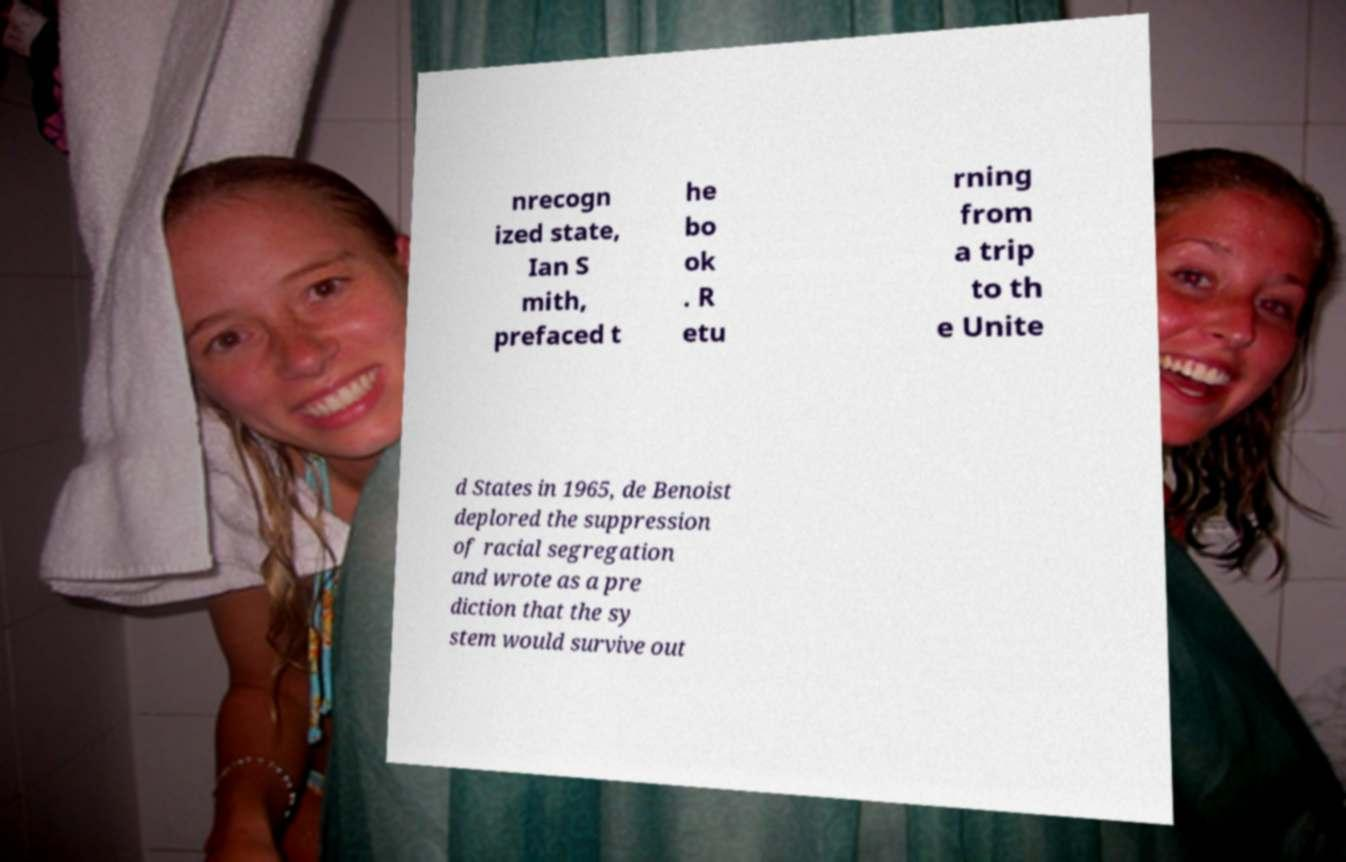Could you assist in decoding the text presented in this image and type it out clearly? nrecogn ized state, Ian S mith, prefaced t he bo ok . R etu rning from a trip to th e Unite d States in 1965, de Benoist deplored the suppression of racial segregation and wrote as a pre diction that the sy stem would survive out 